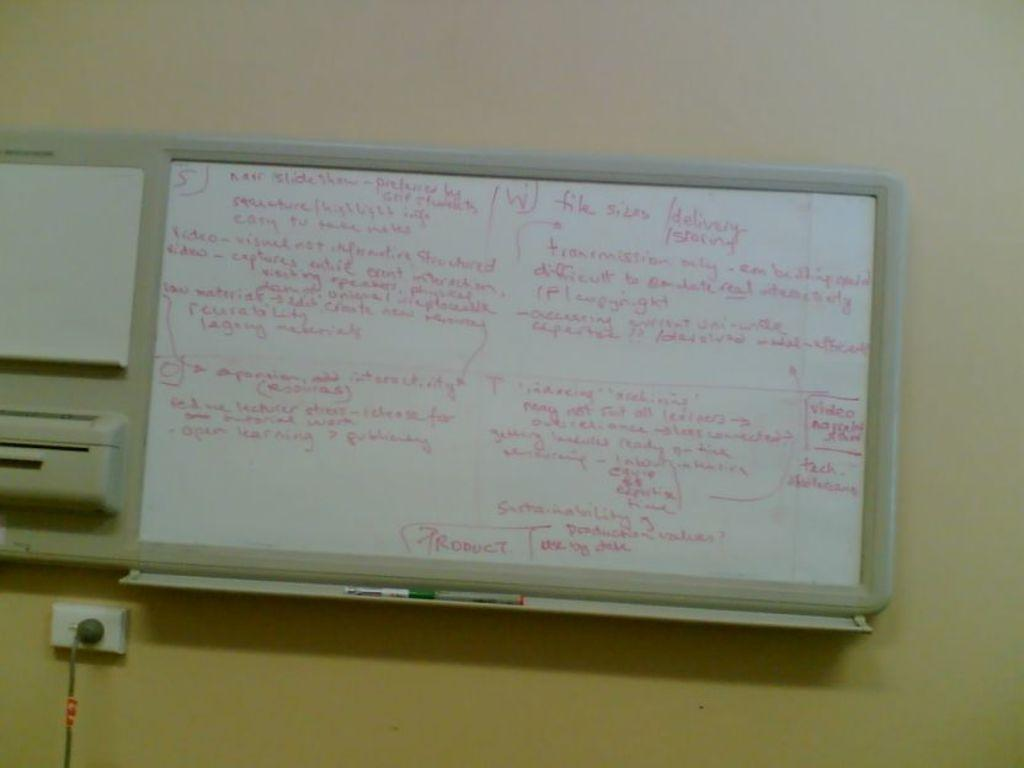What is the main object in the image? There is a board in the image. What type of board is it? It is a switch board. Are there any other objects on the wall in the image? Yes, there are objects on the wall in the image. Can you describe the cable visible in the image? There is a cable visible in the image. What type of badge is pinned on the wall in the image? There is no badge present in the image. Can you describe the stream flowing near the board in the image? There is no stream visible in the image; it only shows a board, a switch board, objects on the wall, and a cable. 